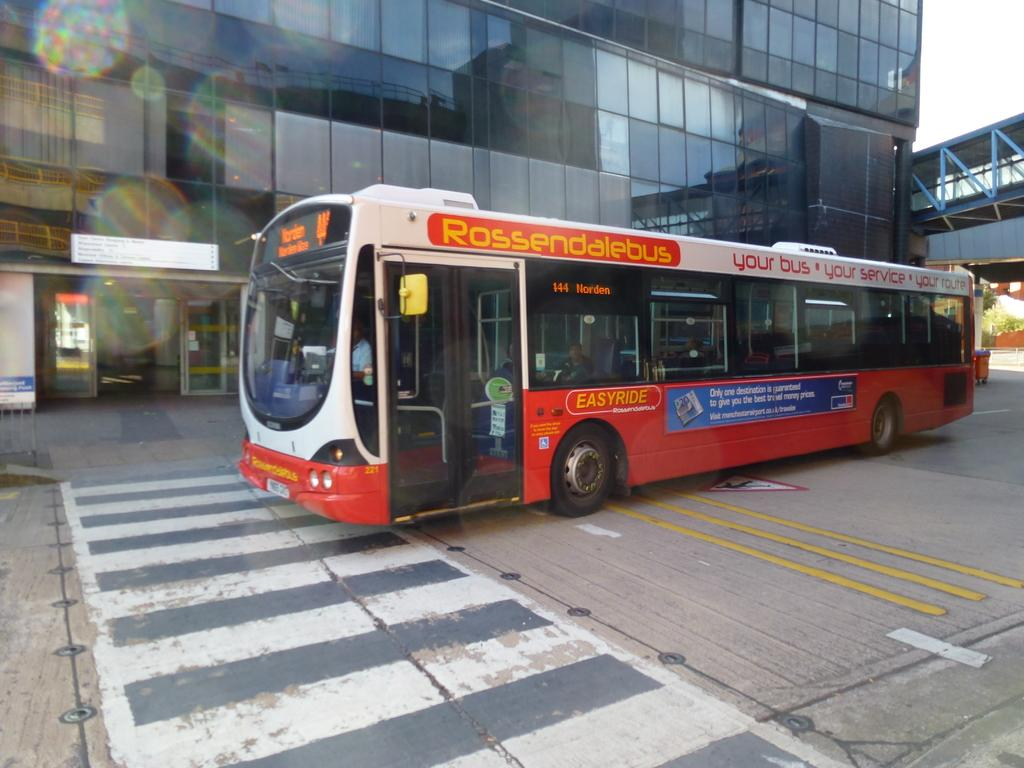<image>
Describe the image concisely. A red and white city bus with Rossendalebus on it. 